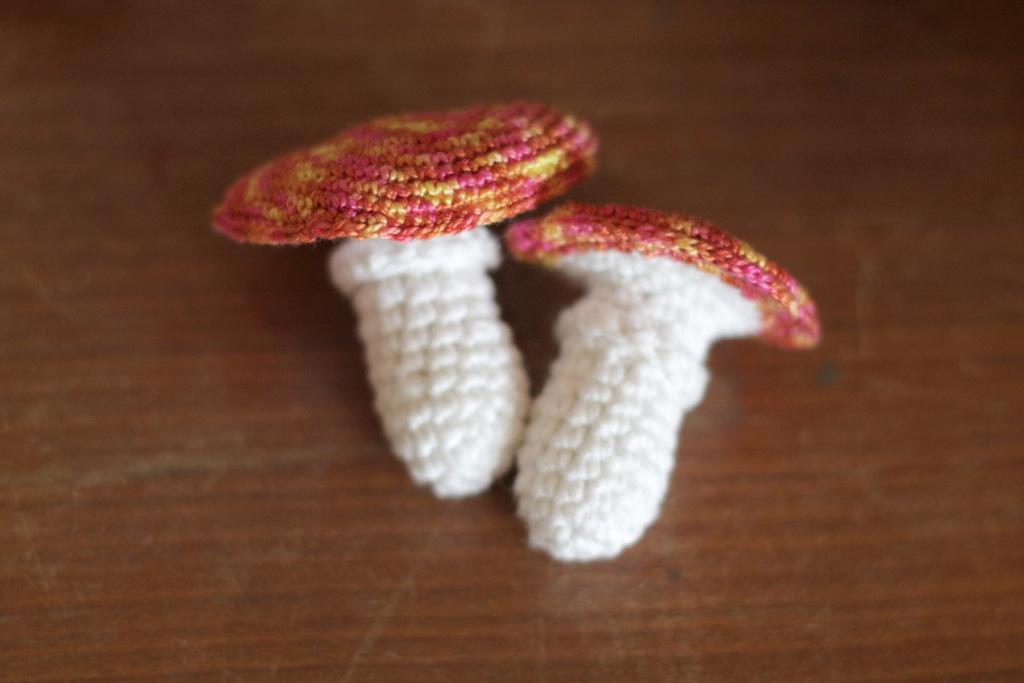Could you give a brief overview of what you see in this image? In this image we can see two white and pink color thing which are made up from threads is kept on the surface. 